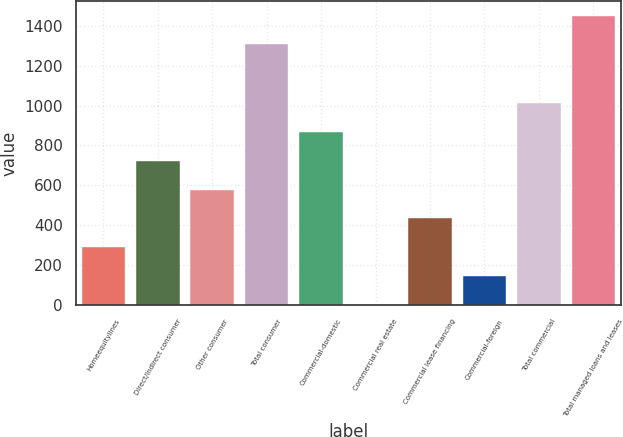Convert chart. <chart><loc_0><loc_0><loc_500><loc_500><bar_chart><fcel>Homeequitylines<fcel>Direct/Indirect consumer<fcel>Other consumer<fcel>Total consumer<fcel>Commercial-domestic<fcel>Commercial real estate<fcel>Commercial lease financing<fcel>Commercial-foreign<fcel>Total commercial<fcel>Total managed loans and leases<nl><fcel>289.8<fcel>723<fcel>578.6<fcel>1307<fcel>867.4<fcel>1<fcel>434.2<fcel>145.4<fcel>1011.8<fcel>1451.4<nl></chart> 